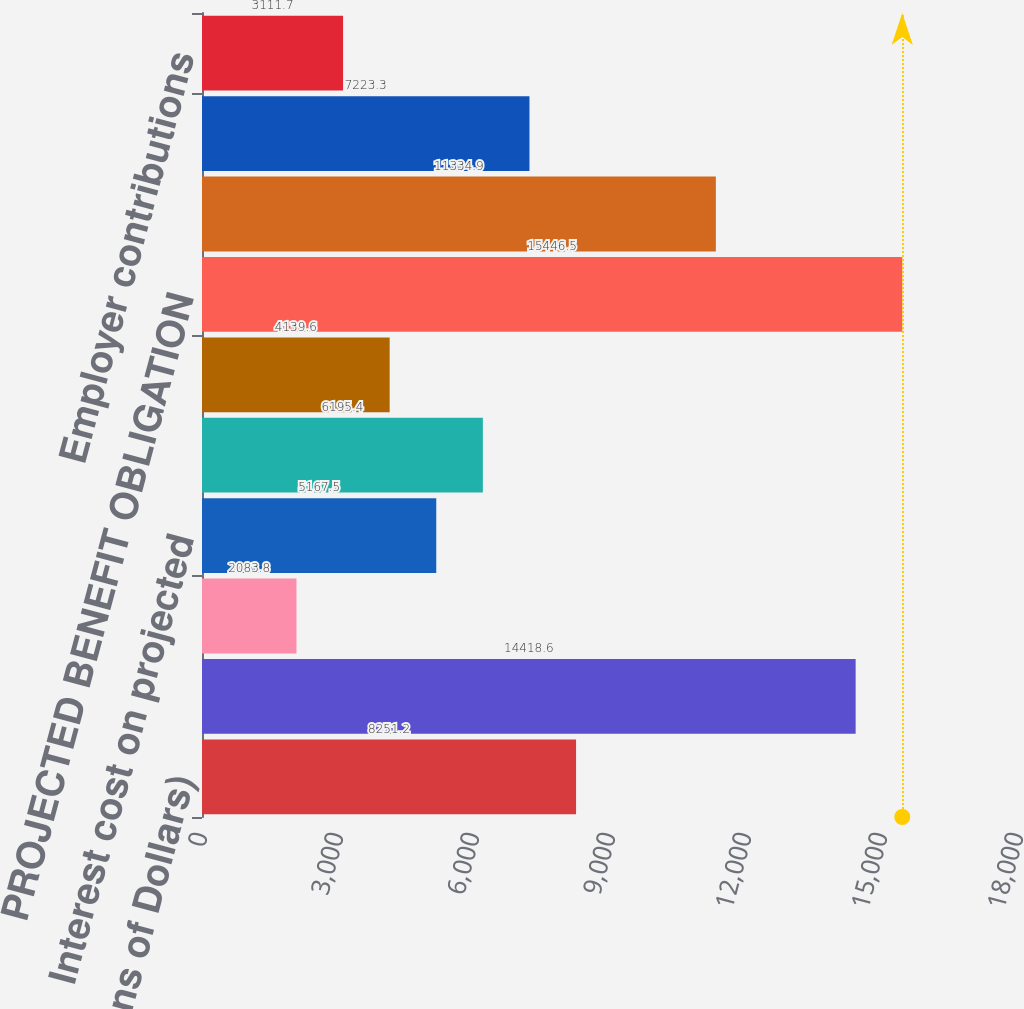Convert chart. <chart><loc_0><loc_0><loc_500><loc_500><bar_chart><fcel>(Millions of Dollars)<fcel>Projected benefit obligation<fcel>Service cost - excluding<fcel>Interest cost on projected<fcel>Net actuarial loss<fcel>Benefits paid<fcel>PROJECTED BENEFIT OBLIGATION<fcel>Fair value of plan assets at<fcel>Actual return on plan assets<fcel>Employer contributions<nl><fcel>8251.2<fcel>14418.6<fcel>2083.8<fcel>5167.5<fcel>6195.4<fcel>4139.6<fcel>15446.5<fcel>11334.9<fcel>7223.3<fcel>3111.7<nl></chart> 